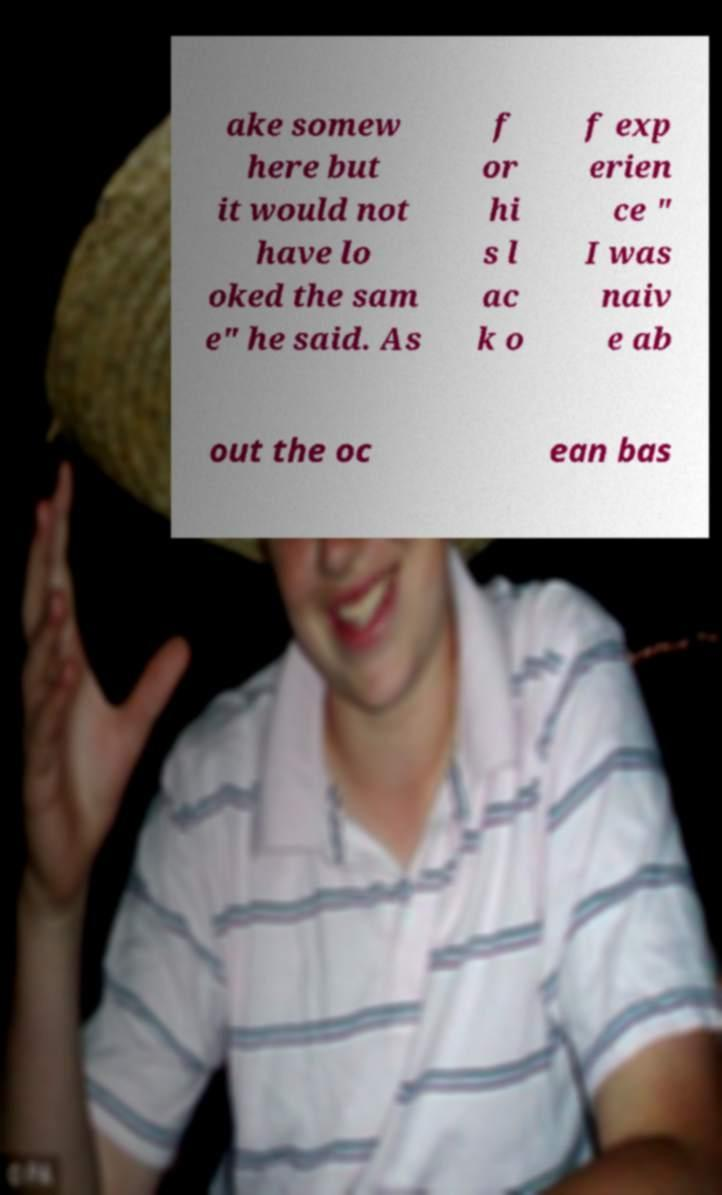Please read and relay the text visible in this image. What does it say? ake somew here but it would not have lo oked the sam e" he said. As f or hi s l ac k o f exp erien ce " I was naiv e ab out the oc ean bas 